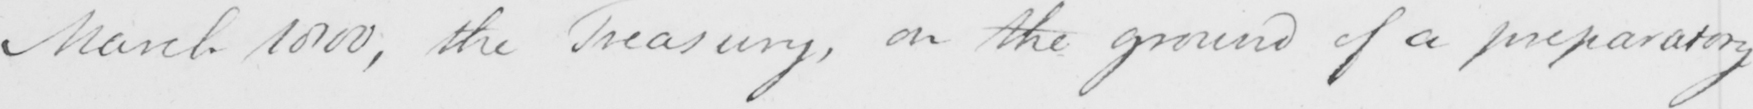Please provide the text content of this handwritten line. March 1800 , the Treasury , on the ground of a preparatory 